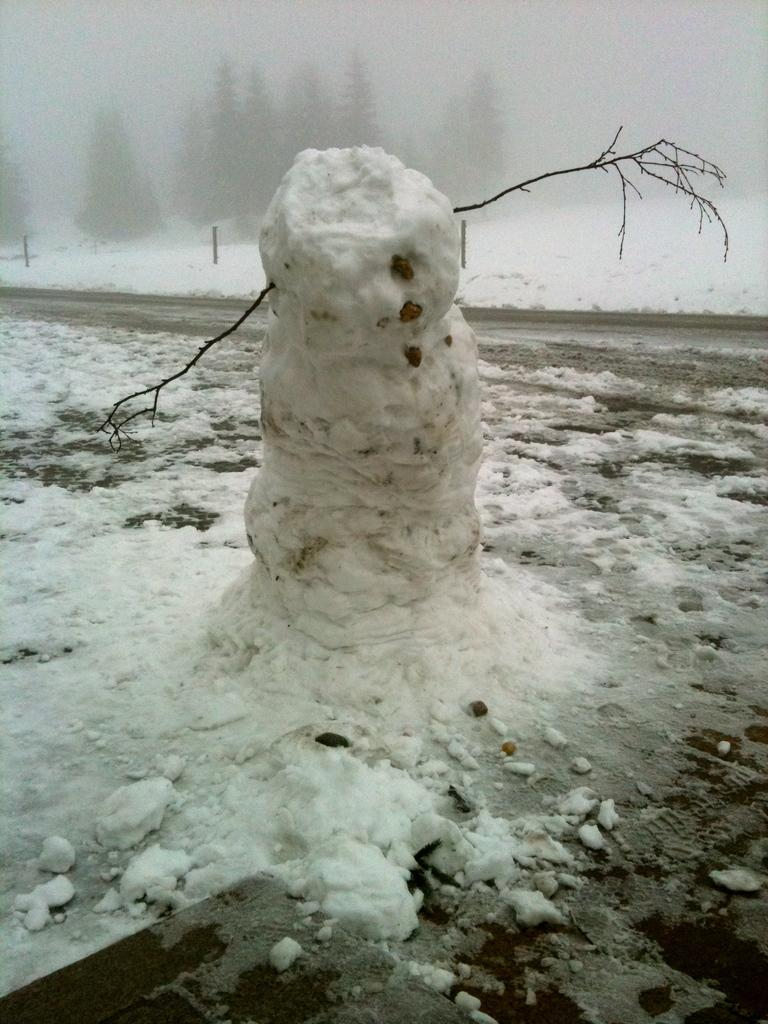What is the main subject in the middle of the image? There is a snowman in the middle of the image. What can be seen in the background of the image? There are trees and snow visible in the background of the image. What type of tray is being used to serve the plants in the image? There is no tray or plants present in the image; it features a snowman and trees in the background. What kind of pie is being baked in the image? There is no pie or baking activity present in the image. 